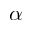<formula> <loc_0><loc_0><loc_500><loc_500>\alpha</formula> 